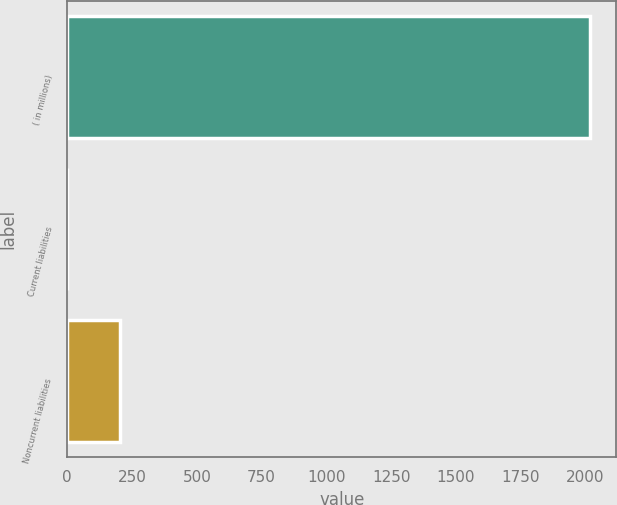Convert chart to OTSL. <chart><loc_0><loc_0><loc_500><loc_500><bar_chart><fcel>( in millions)<fcel>Current liabilities<fcel>Noncurrent liabilities<nl><fcel>2017<fcel>0.7<fcel>202.33<nl></chart> 